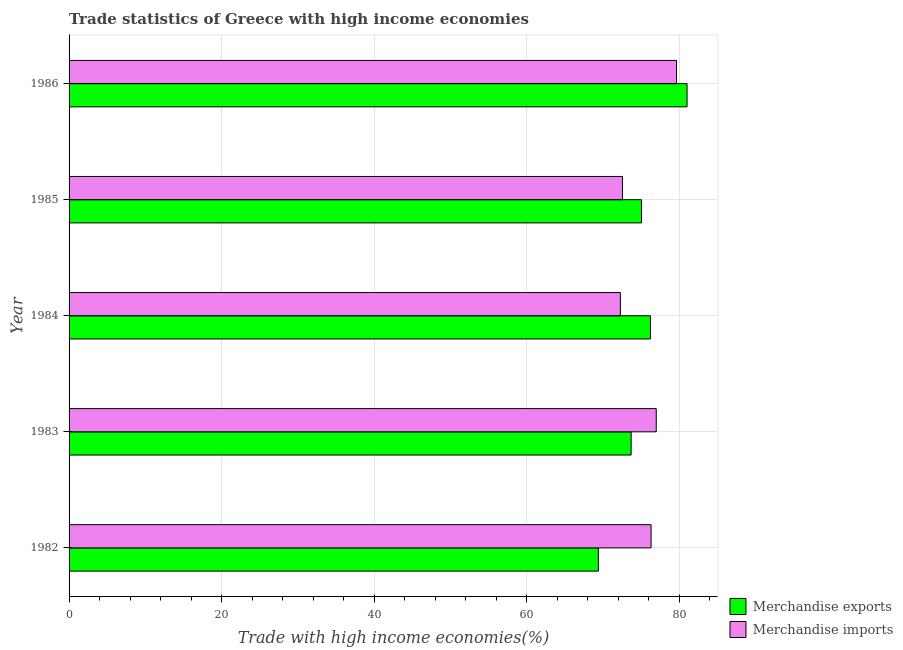Are the number of bars per tick equal to the number of legend labels?
Provide a short and direct response. Yes. Are the number of bars on each tick of the Y-axis equal?
Your response must be concise. Yes. How many bars are there on the 3rd tick from the top?
Provide a succinct answer. 2. How many bars are there on the 5th tick from the bottom?
Keep it short and to the point. 2. What is the merchandise exports in 1984?
Provide a succinct answer. 76.2. Across all years, what is the maximum merchandise exports?
Offer a terse response. 81. Across all years, what is the minimum merchandise imports?
Offer a terse response. 72.25. In which year was the merchandise exports minimum?
Provide a succinct answer. 1982. What is the total merchandise imports in the graph?
Give a very brief answer. 377.64. What is the difference between the merchandise exports in 1982 and that in 1984?
Ensure brevity in your answer.  -6.83. What is the difference between the merchandise imports in 1983 and the merchandise exports in 1986?
Keep it short and to the point. -4.04. What is the average merchandise exports per year?
Offer a terse response. 75.05. In the year 1985, what is the difference between the merchandise imports and merchandise exports?
Give a very brief answer. -2.49. What is the ratio of the merchandise exports in 1983 to that in 1986?
Your answer should be very brief. 0.91. What is the difference between the highest and the second highest merchandise imports?
Your answer should be compact. 2.65. What is the difference between the highest and the lowest merchandise exports?
Your answer should be very brief. 11.62. In how many years, is the merchandise exports greater than the average merchandise exports taken over all years?
Provide a short and direct response. 2. What does the 2nd bar from the top in 1984 represents?
Ensure brevity in your answer.  Merchandise exports. What does the 1st bar from the bottom in 1984 represents?
Provide a short and direct response. Merchandise exports. Are all the bars in the graph horizontal?
Your answer should be very brief. Yes. What is the difference between two consecutive major ticks on the X-axis?
Offer a very short reply. 20. Are the values on the major ticks of X-axis written in scientific E-notation?
Your answer should be compact. No. Does the graph contain grids?
Your response must be concise. Yes. How many legend labels are there?
Your answer should be compact. 2. What is the title of the graph?
Ensure brevity in your answer.  Trade statistics of Greece with high income economies. Does "Crop" appear as one of the legend labels in the graph?
Offer a terse response. No. What is the label or title of the X-axis?
Make the answer very short. Trade with high income economies(%). What is the Trade with high income economies(%) of Merchandise exports in 1982?
Keep it short and to the point. 69.37. What is the Trade with high income economies(%) of Merchandise imports in 1982?
Keep it short and to the point. 76.28. What is the Trade with high income economies(%) of Merchandise exports in 1983?
Give a very brief answer. 73.67. What is the Trade with high income economies(%) in Merchandise imports in 1983?
Make the answer very short. 76.96. What is the Trade with high income economies(%) in Merchandise exports in 1984?
Provide a short and direct response. 76.2. What is the Trade with high income economies(%) in Merchandise imports in 1984?
Make the answer very short. 72.25. What is the Trade with high income economies(%) in Merchandise exports in 1985?
Give a very brief answer. 75.02. What is the Trade with high income economies(%) of Merchandise imports in 1985?
Offer a terse response. 72.53. What is the Trade with high income economies(%) of Merchandise exports in 1986?
Your answer should be very brief. 81. What is the Trade with high income economies(%) of Merchandise imports in 1986?
Keep it short and to the point. 79.61. Across all years, what is the maximum Trade with high income economies(%) in Merchandise exports?
Offer a very short reply. 81. Across all years, what is the maximum Trade with high income economies(%) in Merchandise imports?
Offer a very short reply. 79.61. Across all years, what is the minimum Trade with high income economies(%) of Merchandise exports?
Offer a very short reply. 69.37. Across all years, what is the minimum Trade with high income economies(%) in Merchandise imports?
Your answer should be very brief. 72.25. What is the total Trade with high income economies(%) in Merchandise exports in the graph?
Your response must be concise. 375.25. What is the total Trade with high income economies(%) of Merchandise imports in the graph?
Provide a succinct answer. 377.64. What is the difference between the Trade with high income economies(%) in Merchandise exports in 1982 and that in 1983?
Provide a short and direct response. -4.3. What is the difference between the Trade with high income economies(%) of Merchandise imports in 1982 and that in 1983?
Offer a terse response. -0.68. What is the difference between the Trade with high income economies(%) in Merchandise exports in 1982 and that in 1984?
Your answer should be very brief. -6.83. What is the difference between the Trade with high income economies(%) of Merchandise imports in 1982 and that in 1984?
Provide a short and direct response. 4.03. What is the difference between the Trade with high income economies(%) in Merchandise exports in 1982 and that in 1985?
Ensure brevity in your answer.  -5.65. What is the difference between the Trade with high income economies(%) of Merchandise imports in 1982 and that in 1985?
Provide a short and direct response. 3.75. What is the difference between the Trade with high income economies(%) of Merchandise exports in 1982 and that in 1986?
Your answer should be very brief. -11.62. What is the difference between the Trade with high income economies(%) of Merchandise imports in 1982 and that in 1986?
Your answer should be very brief. -3.33. What is the difference between the Trade with high income economies(%) in Merchandise exports in 1983 and that in 1984?
Your response must be concise. -2.53. What is the difference between the Trade with high income economies(%) in Merchandise imports in 1983 and that in 1984?
Provide a succinct answer. 4.7. What is the difference between the Trade with high income economies(%) of Merchandise exports in 1983 and that in 1985?
Offer a very short reply. -1.35. What is the difference between the Trade with high income economies(%) in Merchandise imports in 1983 and that in 1985?
Make the answer very short. 4.42. What is the difference between the Trade with high income economies(%) in Merchandise exports in 1983 and that in 1986?
Your response must be concise. -7.33. What is the difference between the Trade with high income economies(%) of Merchandise imports in 1983 and that in 1986?
Offer a terse response. -2.65. What is the difference between the Trade with high income economies(%) in Merchandise exports in 1984 and that in 1985?
Give a very brief answer. 1.18. What is the difference between the Trade with high income economies(%) of Merchandise imports in 1984 and that in 1985?
Your answer should be very brief. -0.28. What is the difference between the Trade with high income economies(%) in Merchandise exports in 1984 and that in 1986?
Your answer should be very brief. -4.8. What is the difference between the Trade with high income economies(%) of Merchandise imports in 1984 and that in 1986?
Provide a short and direct response. -7.36. What is the difference between the Trade with high income economies(%) in Merchandise exports in 1985 and that in 1986?
Ensure brevity in your answer.  -5.98. What is the difference between the Trade with high income economies(%) of Merchandise imports in 1985 and that in 1986?
Your answer should be compact. -7.08. What is the difference between the Trade with high income economies(%) of Merchandise exports in 1982 and the Trade with high income economies(%) of Merchandise imports in 1983?
Your response must be concise. -7.59. What is the difference between the Trade with high income economies(%) in Merchandise exports in 1982 and the Trade with high income economies(%) in Merchandise imports in 1984?
Provide a succinct answer. -2.88. What is the difference between the Trade with high income economies(%) in Merchandise exports in 1982 and the Trade with high income economies(%) in Merchandise imports in 1985?
Offer a terse response. -3.16. What is the difference between the Trade with high income economies(%) of Merchandise exports in 1982 and the Trade with high income economies(%) of Merchandise imports in 1986?
Keep it short and to the point. -10.24. What is the difference between the Trade with high income economies(%) of Merchandise exports in 1983 and the Trade with high income economies(%) of Merchandise imports in 1984?
Your response must be concise. 1.41. What is the difference between the Trade with high income economies(%) in Merchandise exports in 1983 and the Trade with high income economies(%) in Merchandise imports in 1985?
Offer a terse response. 1.13. What is the difference between the Trade with high income economies(%) in Merchandise exports in 1983 and the Trade with high income economies(%) in Merchandise imports in 1986?
Make the answer very short. -5.95. What is the difference between the Trade with high income economies(%) in Merchandise exports in 1984 and the Trade with high income economies(%) in Merchandise imports in 1985?
Make the answer very short. 3.67. What is the difference between the Trade with high income economies(%) of Merchandise exports in 1984 and the Trade with high income economies(%) of Merchandise imports in 1986?
Provide a short and direct response. -3.41. What is the difference between the Trade with high income economies(%) of Merchandise exports in 1985 and the Trade with high income economies(%) of Merchandise imports in 1986?
Offer a very short reply. -4.59. What is the average Trade with high income economies(%) of Merchandise exports per year?
Provide a succinct answer. 75.05. What is the average Trade with high income economies(%) in Merchandise imports per year?
Make the answer very short. 75.53. In the year 1982, what is the difference between the Trade with high income economies(%) in Merchandise exports and Trade with high income economies(%) in Merchandise imports?
Your answer should be very brief. -6.91. In the year 1983, what is the difference between the Trade with high income economies(%) of Merchandise exports and Trade with high income economies(%) of Merchandise imports?
Offer a terse response. -3.29. In the year 1984, what is the difference between the Trade with high income economies(%) in Merchandise exports and Trade with high income economies(%) in Merchandise imports?
Your answer should be very brief. 3.94. In the year 1985, what is the difference between the Trade with high income economies(%) in Merchandise exports and Trade with high income economies(%) in Merchandise imports?
Provide a short and direct response. 2.49. In the year 1986, what is the difference between the Trade with high income economies(%) of Merchandise exports and Trade with high income economies(%) of Merchandise imports?
Provide a short and direct response. 1.38. What is the ratio of the Trade with high income economies(%) of Merchandise exports in 1982 to that in 1983?
Ensure brevity in your answer.  0.94. What is the ratio of the Trade with high income economies(%) in Merchandise imports in 1982 to that in 1983?
Make the answer very short. 0.99. What is the ratio of the Trade with high income economies(%) in Merchandise exports in 1982 to that in 1984?
Provide a succinct answer. 0.91. What is the ratio of the Trade with high income economies(%) in Merchandise imports in 1982 to that in 1984?
Make the answer very short. 1.06. What is the ratio of the Trade with high income economies(%) in Merchandise exports in 1982 to that in 1985?
Offer a very short reply. 0.92. What is the ratio of the Trade with high income economies(%) in Merchandise imports in 1982 to that in 1985?
Offer a terse response. 1.05. What is the ratio of the Trade with high income economies(%) of Merchandise exports in 1982 to that in 1986?
Keep it short and to the point. 0.86. What is the ratio of the Trade with high income economies(%) of Merchandise imports in 1982 to that in 1986?
Provide a short and direct response. 0.96. What is the ratio of the Trade with high income economies(%) in Merchandise exports in 1983 to that in 1984?
Provide a succinct answer. 0.97. What is the ratio of the Trade with high income economies(%) of Merchandise imports in 1983 to that in 1984?
Offer a terse response. 1.07. What is the ratio of the Trade with high income economies(%) of Merchandise imports in 1983 to that in 1985?
Offer a very short reply. 1.06. What is the ratio of the Trade with high income economies(%) of Merchandise exports in 1983 to that in 1986?
Your answer should be compact. 0.91. What is the ratio of the Trade with high income economies(%) of Merchandise imports in 1983 to that in 1986?
Provide a succinct answer. 0.97. What is the ratio of the Trade with high income economies(%) in Merchandise exports in 1984 to that in 1985?
Provide a short and direct response. 1.02. What is the ratio of the Trade with high income economies(%) in Merchandise imports in 1984 to that in 1985?
Your answer should be compact. 1. What is the ratio of the Trade with high income economies(%) in Merchandise exports in 1984 to that in 1986?
Provide a succinct answer. 0.94. What is the ratio of the Trade with high income economies(%) in Merchandise imports in 1984 to that in 1986?
Ensure brevity in your answer.  0.91. What is the ratio of the Trade with high income economies(%) of Merchandise exports in 1985 to that in 1986?
Make the answer very short. 0.93. What is the ratio of the Trade with high income economies(%) in Merchandise imports in 1985 to that in 1986?
Keep it short and to the point. 0.91. What is the difference between the highest and the second highest Trade with high income economies(%) of Merchandise exports?
Offer a very short reply. 4.8. What is the difference between the highest and the second highest Trade with high income economies(%) of Merchandise imports?
Provide a succinct answer. 2.65. What is the difference between the highest and the lowest Trade with high income economies(%) in Merchandise exports?
Offer a very short reply. 11.62. What is the difference between the highest and the lowest Trade with high income economies(%) of Merchandise imports?
Offer a terse response. 7.36. 